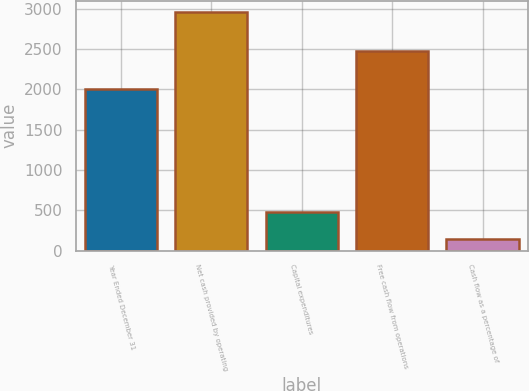Convert chart. <chart><loc_0><loc_0><loc_500><loc_500><bar_chart><fcel>Year Ended December 31<fcel>Net cash provided by operating<fcel>Capital expenditures<fcel>Free cash flow from operations<fcel>Cash flow as a percentage of<nl><fcel>2007<fcel>2952<fcel>474<fcel>2478<fcel>142<nl></chart> 